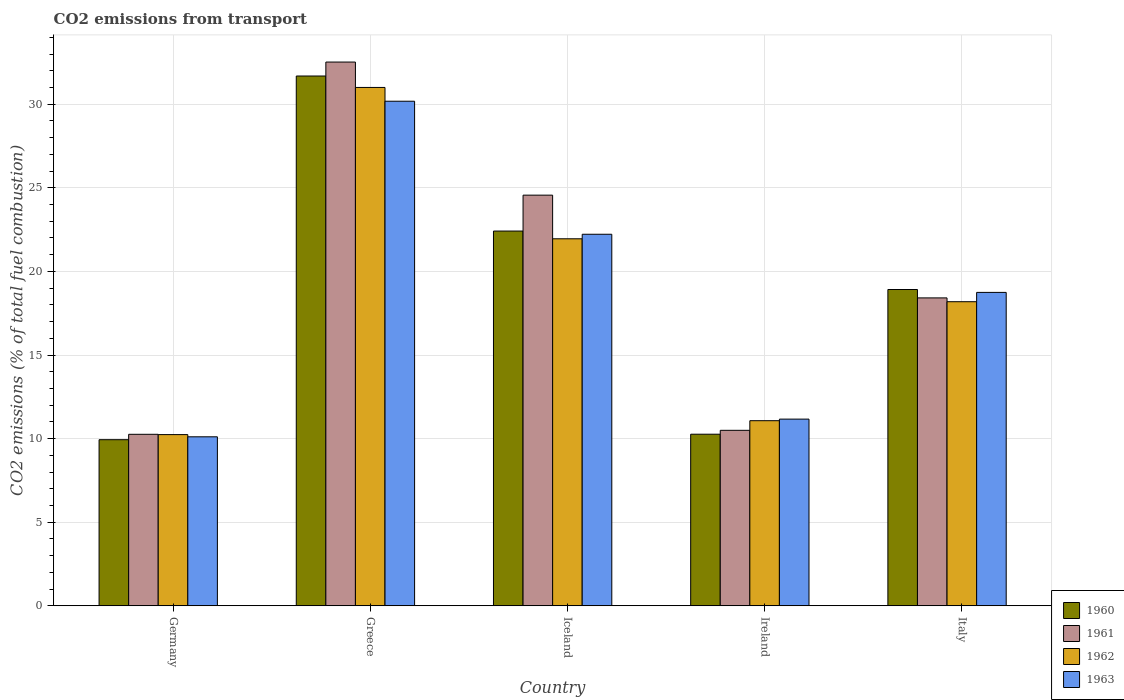How many groups of bars are there?
Provide a succinct answer. 5. What is the label of the 5th group of bars from the left?
Keep it short and to the point. Italy. What is the total CO2 emitted in 1962 in Iceland?
Give a very brief answer. 21.95. Across all countries, what is the maximum total CO2 emitted in 1963?
Your answer should be very brief. 30.18. Across all countries, what is the minimum total CO2 emitted in 1960?
Make the answer very short. 9.93. In which country was the total CO2 emitted in 1961 maximum?
Give a very brief answer. Greece. What is the total total CO2 emitted in 1961 in the graph?
Keep it short and to the point. 96.25. What is the difference between the total CO2 emitted in 1961 in Germany and that in Greece?
Offer a very short reply. -22.26. What is the difference between the total CO2 emitted in 1960 in Greece and the total CO2 emitted in 1962 in Iceland?
Make the answer very short. 9.74. What is the average total CO2 emitted in 1963 per country?
Your answer should be compact. 18.48. What is the difference between the total CO2 emitted of/in 1962 and total CO2 emitted of/in 1963 in Iceland?
Keep it short and to the point. -0.27. In how many countries, is the total CO2 emitted in 1963 greater than 1?
Ensure brevity in your answer.  5. What is the ratio of the total CO2 emitted in 1961 in Iceland to that in Italy?
Provide a succinct answer. 1.33. Is the total CO2 emitted in 1963 in Greece less than that in Iceland?
Offer a very short reply. No. Is the difference between the total CO2 emitted in 1962 in Greece and Italy greater than the difference between the total CO2 emitted in 1963 in Greece and Italy?
Offer a very short reply. Yes. What is the difference between the highest and the second highest total CO2 emitted in 1963?
Your response must be concise. -11.43. What is the difference between the highest and the lowest total CO2 emitted in 1962?
Your answer should be compact. 20.76. In how many countries, is the total CO2 emitted in 1961 greater than the average total CO2 emitted in 1961 taken over all countries?
Give a very brief answer. 2. Is it the case that in every country, the sum of the total CO2 emitted in 1962 and total CO2 emitted in 1960 is greater than the sum of total CO2 emitted in 1963 and total CO2 emitted in 1961?
Ensure brevity in your answer.  No. What does the 3rd bar from the left in Germany represents?
Your answer should be compact. 1962. What does the 4th bar from the right in Greece represents?
Provide a short and direct response. 1960. How many bars are there?
Your answer should be compact. 20. Are all the bars in the graph horizontal?
Your answer should be compact. No. How many countries are there in the graph?
Give a very brief answer. 5. Are the values on the major ticks of Y-axis written in scientific E-notation?
Keep it short and to the point. No. How many legend labels are there?
Offer a very short reply. 4. What is the title of the graph?
Your answer should be compact. CO2 emissions from transport. What is the label or title of the X-axis?
Offer a very short reply. Country. What is the label or title of the Y-axis?
Make the answer very short. CO2 emissions (% of total fuel combustion). What is the CO2 emissions (% of total fuel combustion) of 1960 in Germany?
Give a very brief answer. 9.93. What is the CO2 emissions (% of total fuel combustion) of 1961 in Germany?
Your answer should be compact. 10.26. What is the CO2 emissions (% of total fuel combustion) of 1962 in Germany?
Give a very brief answer. 10.24. What is the CO2 emissions (% of total fuel combustion) in 1963 in Germany?
Keep it short and to the point. 10.11. What is the CO2 emissions (% of total fuel combustion) of 1960 in Greece?
Make the answer very short. 31.69. What is the CO2 emissions (% of total fuel combustion) of 1961 in Greece?
Give a very brief answer. 32.52. What is the CO2 emissions (% of total fuel combustion) of 1962 in Greece?
Give a very brief answer. 31. What is the CO2 emissions (% of total fuel combustion) of 1963 in Greece?
Keep it short and to the point. 30.18. What is the CO2 emissions (% of total fuel combustion) in 1960 in Iceland?
Ensure brevity in your answer.  22.41. What is the CO2 emissions (% of total fuel combustion) in 1961 in Iceland?
Your answer should be very brief. 24.56. What is the CO2 emissions (% of total fuel combustion) in 1962 in Iceland?
Ensure brevity in your answer.  21.95. What is the CO2 emissions (% of total fuel combustion) of 1963 in Iceland?
Keep it short and to the point. 22.22. What is the CO2 emissions (% of total fuel combustion) in 1960 in Ireland?
Keep it short and to the point. 10.26. What is the CO2 emissions (% of total fuel combustion) of 1961 in Ireland?
Provide a short and direct response. 10.5. What is the CO2 emissions (% of total fuel combustion) in 1962 in Ireland?
Offer a very short reply. 11.07. What is the CO2 emissions (% of total fuel combustion) in 1963 in Ireland?
Offer a very short reply. 11.17. What is the CO2 emissions (% of total fuel combustion) of 1960 in Italy?
Provide a short and direct response. 18.92. What is the CO2 emissions (% of total fuel combustion) of 1961 in Italy?
Offer a terse response. 18.42. What is the CO2 emissions (% of total fuel combustion) of 1962 in Italy?
Offer a very short reply. 18.19. What is the CO2 emissions (% of total fuel combustion) of 1963 in Italy?
Keep it short and to the point. 18.74. Across all countries, what is the maximum CO2 emissions (% of total fuel combustion) in 1960?
Give a very brief answer. 31.69. Across all countries, what is the maximum CO2 emissions (% of total fuel combustion) of 1961?
Give a very brief answer. 32.52. Across all countries, what is the maximum CO2 emissions (% of total fuel combustion) of 1962?
Provide a succinct answer. 31. Across all countries, what is the maximum CO2 emissions (% of total fuel combustion) of 1963?
Provide a short and direct response. 30.18. Across all countries, what is the minimum CO2 emissions (% of total fuel combustion) of 1960?
Your answer should be compact. 9.93. Across all countries, what is the minimum CO2 emissions (% of total fuel combustion) in 1961?
Make the answer very short. 10.26. Across all countries, what is the minimum CO2 emissions (% of total fuel combustion) of 1962?
Your response must be concise. 10.24. Across all countries, what is the minimum CO2 emissions (% of total fuel combustion) in 1963?
Provide a succinct answer. 10.11. What is the total CO2 emissions (% of total fuel combustion) in 1960 in the graph?
Offer a terse response. 93.21. What is the total CO2 emissions (% of total fuel combustion) of 1961 in the graph?
Give a very brief answer. 96.25. What is the total CO2 emissions (% of total fuel combustion) of 1962 in the graph?
Offer a terse response. 92.45. What is the total CO2 emissions (% of total fuel combustion) of 1963 in the graph?
Offer a terse response. 92.42. What is the difference between the CO2 emissions (% of total fuel combustion) in 1960 in Germany and that in Greece?
Your answer should be very brief. -21.75. What is the difference between the CO2 emissions (% of total fuel combustion) of 1961 in Germany and that in Greece?
Offer a very short reply. -22.26. What is the difference between the CO2 emissions (% of total fuel combustion) of 1962 in Germany and that in Greece?
Your response must be concise. -20.76. What is the difference between the CO2 emissions (% of total fuel combustion) in 1963 in Germany and that in Greece?
Give a very brief answer. -20.07. What is the difference between the CO2 emissions (% of total fuel combustion) in 1960 in Germany and that in Iceland?
Offer a terse response. -12.48. What is the difference between the CO2 emissions (% of total fuel combustion) in 1961 in Germany and that in Iceland?
Your answer should be compact. -14.3. What is the difference between the CO2 emissions (% of total fuel combustion) of 1962 in Germany and that in Iceland?
Keep it short and to the point. -11.71. What is the difference between the CO2 emissions (% of total fuel combustion) of 1963 in Germany and that in Iceland?
Your answer should be very brief. -12.12. What is the difference between the CO2 emissions (% of total fuel combustion) in 1960 in Germany and that in Ireland?
Ensure brevity in your answer.  -0.33. What is the difference between the CO2 emissions (% of total fuel combustion) in 1961 in Germany and that in Ireland?
Ensure brevity in your answer.  -0.24. What is the difference between the CO2 emissions (% of total fuel combustion) in 1962 in Germany and that in Ireland?
Your answer should be very brief. -0.83. What is the difference between the CO2 emissions (% of total fuel combustion) in 1963 in Germany and that in Ireland?
Ensure brevity in your answer.  -1.06. What is the difference between the CO2 emissions (% of total fuel combustion) of 1960 in Germany and that in Italy?
Provide a short and direct response. -8.98. What is the difference between the CO2 emissions (% of total fuel combustion) of 1961 in Germany and that in Italy?
Ensure brevity in your answer.  -8.16. What is the difference between the CO2 emissions (% of total fuel combustion) of 1962 in Germany and that in Italy?
Provide a short and direct response. -7.95. What is the difference between the CO2 emissions (% of total fuel combustion) in 1963 in Germany and that in Italy?
Your answer should be compact. -8.64. What is the difference between the CO2 emissions (% of total fuel combustion) in 1960 in Greece and that in Iceland?
Give a very brief answer. 9.27. What is the difference between the CO2 emissions (% of total fuel combustion) of 1961 in Greece and that in Iceland?
Ensure brevity in your answer.  7.96. What is the difference between the CO2 emissions (% of total fuel combustion) of 1962 in Greece and that in Iceland?
Give a very brief answer. 9.05. What is the difference between the CO2 emissions (% of total fuel combustion) of 1963 in Greece and that in Iceland?
Make the answer very short. 7.96. What is the difference between the CO2 emissions (% of total fuel combustion) in 1960 in Greece and that in Ireland?
Ensure brevity in your answer.  21.42. What is the difference between the CO2 emissions (% of total fuel combustion) of 1961 in Greece and that in Ireland?
Provide a succinct answer. 22.03. What is the difference between the CO2 emissions (% of total fuel combustion) in 1962 in Greece and that in Ireland?
Offer a terse response. 19.93. What is the difference between the CO2 emissions (% of total fuel combustion) of 1963 in Greece and that in Ireland?
Provide a succinct answer. 19.01. What is the difference between the CO2 emissions (% of total fuel combustion) in 1960 in Greece and that in Italy?
Ensure brevity in your answer.  12.77. What is the difference between the CO2 emissions (% of total fuel combustion) in 1961 in Greece and that in Italy?
Your answer should be very brief. 14.11. What is the difference between the CO2 emissions (% of total fuel combustion) in 1962 in Greece and that in Italy?
Provide a succinct answer. 12.82. What is the difference between the CO2 emissions (% of total fuel combustion) in 1963 in Greece and that in Italy?
Your response must be concise. 11.43. What is the difference between the CO2 emissions (% of total fuel combustion) of 1960 in Iceland and that in Ireland?
Keep it short and to the point. 12.15. What is the difference between the CO2 emissions (% of total fuel combustion) in 1961 in Iceland and that in Ireland?
Keep it short and to the point. 14.07. What is the difference between the CO2 emissions (% of total fuel combustion) of 1962 in Iceland and that in Ireland?
Your response must be concise. 10.88. What is the difference between the CO2 emissions (% of total fuel combustion) in 1963 in Iceland and that in Ireland?
Your answer should be very brief. 11.06. What is the difference between the CO2 emissions (% of total fuel combustion) of 1960 in Iceland and that in Italy?
Provide a succinct answer. 3.5. What is the difference between the CO2 emissions (% of total fuel combustion) of 1961 in Iceland and that in Italy?
Make the answer very short. 6.15. What is the difference between the CO2 emissions (% of total fuel combustion) in 1962 in Iceland and that in Italy?
Provide a succinct answer. 3.76. What is the difference between the CO2 emissions (% of total fuel combustion) of 1963 in Iceland and that in Italy?
Your answer should be compact. 3.48. What is the difference between the CO2 emissions (% of total fuel combustion) of 1960 in Ireland and that in Italy?
Make the answer very short. -8.65. What is the difference between the CO2 emissions (% of total fuel combustion) in 1961 in Ireland and that in Italy?
Make the answer very short. -7.92. What is the difference between the CO2 emissions (% of total fuel combustion) of 1962 in Ireland and that in Italy?
Provide a succinct answer. -7.12. What is the difference between the CO2 emissions (% of total fuel combustion) of 1963 in Ireland and that in Italy?
Make the answer very short. -7.58. What is the difference between the CO2 emissions (% of total fuel combustion) in 1960 in Germany and the CO2 emissions (% of total fuel combustion) in 1961 in Greece?
Make the answer very short. -22.59. What is the difference between the CO2 emissions (% of total fuel combustion) in 1960 in Germany and the CO2 emissions (% of total fuel combustion) in 1962 in Greece?
Your answer should be compact. -21.07. What is the difference between the CO2 emissions (% of total fuel combustion) in 1960 in Germany and the CO2 emissions (% of total fuel combustion) in 1963 in Greece?
Provide a short and direct response. -20.24. What is the difference between the CO2 emissions (% of total fuel combustion) in 1961 in Germany and the CO2 emissions (% of total fuel combustion) in 1962 in Greece?
Your response must be concise. -20.75. What is the difference between the CO2 emissions (% of total fuel combustion) in 1961 in Germany and the CO2 emissions (% of total fuel combustion) in 1963 in Greece?
Your answer should be compact. -19.92. What is the difference between the CO2 emissions (% of total fuel combustion) in 1962 in Germany and the CO2 emissions (% of total fuel combustion) in 1963 in Greece?
Ensure brevity in your answer.  -19.94. What is the difference between the CO2 emissions (% of total fuel combustion) in 1960 in Germany and the CO2 emissions (% of total fuel combustion) in 1961 in Iceland?
Your response must be concise. -14.63. What is the difference between the CO2 emissions (% of total fuel combustion) in 1960 in Germany and the CO2 emissions (% of total fuel combustion) in 1962 in Iceland?
Provide a succinct answer. -12.02. What is the difference between the CO2 emissions (% of total fuel combustion) in 1960 in Germany and the CO2 emissions (% of total fuel combustion) in 1963 in Iceland?
Offer a terse response. -12.29. What is the difference between the CO2 emissions (% of total fuel combustion) of 1961 in Germany and the CO2 emissions (% of total fuel combustion) of 1962 in Iceland?
Provide a short and direct response. -11.69. What is the difference between the CO2 emissions (% of total fuel combustion) of 1961 in Germany and the CO2 emissions (% of total fuel combustion) of 1963 in Iceland?
Make the answer very short. -11.96. What is the difference between the CO2 emissions (% of total fuel combustion) in 1962 in Germany and the CO2 emissions (% of total fuel combustion) in 1963 in Iceland?
Your answer should be compact. -11.98. What is the difference between the CO2 emissions (% of total fuel combustion) in 1960 in Germany and the CO2 emissions (% of total fuel combustion) in 1961 in Ireland?
Your response must be concise. -0.56. What is the difference between the CO2 emissions (% of total fuel combustion) in 1960 in Germany and the CO2 emissions (% of total fuel combustion) in 1962 in Ireland?
Keep it short and to the point. -1.14. What is the difference between the CO2 emissions (% of total fuel combustion) in 1960 in Germany and the CO2 emissions (% of total fuel combustion) in 1963 in Ireland?
Provide a short and direct response. -1.23. What is the difference between the CO2 emissions (% of total fuel combustion) of 1961 in Germany and the CO2 emissions (% of total fuel combustion) of 1962 in Ireland?
Provide a succinct answer. -0.81. What is the difference between the CO2 emissions (% of total fuel combustion) in 1961 in Germany and the CO2 emissions (% of total fuel combustion) in 1963 in Ireland?
Offer a terse response. -0.91. What is the difference between the CO2 emissions (% of total fuel combustion) of 1962 in Germany and the CO2 emissions (% of total fuel combustion) of 1963 in Ireland?
Your answer should be very brief. -0.93. What is the difference between the CO2 emissions (% of total fuel combustion) of 1960 in Germany and the CO2 emissions (% of total fuel combustion) of 1961 in Italy?
Your answer should be compact. -8.48. What is the difference between the CO2 emissions (% of total fuel combustion) in 1960 in Germany and the CO2 emissions (% of total fuel combustion) in 1962 in Italy?
Offer a terse response. -8.25. What is the difference between the CO2 emissions (% of total fuel combustion) of 1960 in Germany and the CO2 emissions (% of total fuel combustion) of 1963 in Italy?
Give a very brief answer. -8.81. What is the difference between the CO2 emissions (% of total fuel combustion) in 1961 in Germany and the CO2 emissions (% of total fuel combustion) in 1962 in Italy?
Your answer should be compact. -7.93. What is the difference between the CO2 emissions (% of total fuel combustion) of 1961 in Germany and the CO2 emissions (% of total fuel combustion) of 1963 in Italy?
Your answer should be very brief. -8.49. What is the difference between the CO2 emissions (% of total fuel combustion) in 1962 in Germany and the CO2 emissions (% of total fuel combustion) in 1963 in Italy?
Provide a succinct answer. -8.51. What is the difference between the CO2 emissions (% of total fuel combustion) in 1960 in Greece and the CO2 emissions (% of total fuel combustion) in 1961 in Iceland?
Provide a succinct answer. 7.13. What is the difference between the CO2 emissions (% of total fuel combustion) of 1960 in Greece and the CO2 emissions (% of total fuel combustion) of 1962 in Iceland?
Make the answer very short. 9.74. What is the difference between the CO2 emissions (% of total fuel combustion) of 1960 in Greece and the CO2 emissions (% of total fuel combustion) of 1963 in Iceland?
Ensure brevity in your answer.  9.46. What is the difference between the CO2 emissions (% of total fuel combustion) of 1961 in Greece and the CO2 emissions (% of total fuel combustion) of 1962 in Iceland?
Ensure brevity in your answer.  10.57. What is the difference between the CO2 emissions (% of total fuel combustion) of 1961 in Greece and the CO2 emissions (% of total fuel combustion) of 1963 in Iceland?
Provide a short and direct response. 10.3. What is the difference between the CO2 emissions (% of total fuel combustion) of 1962 in Greece and the CO2 emissions (% of total fuel combustion) of 1963 in Iceland?
Make the answer very short. 8.78. What is the difference between the CO2 emissions (% of total fuel combustion) in 1960 in Greece and the CO2 emissions (% of total fuel combustion) in 1961 in Ireland?
Offer a terse response. 21.19. What is the difference between the CO2 emissions (% of total fuel combustion) in 1960 in Greece and the CO2 emissions (% of total fuel combustion) in 1962 in Ireland?
Provide a succinct answer. 20.62. What is the difference between the CO2 emissions (% of total fuel combustion) in 1960 in Greece and the CO2 emissions (% of total fuel combustion) in 1963 in Ireland?
Keep it short and to the point. 20.52. What is the difference between the CO2 emissions (% of total fuel combustion) in 1961 in Greece and the CO2 emissions (% of total fuel combustion) in 1962 in Ireland?
Give a very brief answer. 21.45. What is the difference between the CO2 emissions (% of total fuel combustion) in 1961 in Greece and the CO2 emissions (% of total fuel combustion) in 1963 in Ireland?
Offer a terse response. 21.36. What is the difference between the CO2 emissions (% of total fuel combustion) of 1962 in Greece and the CO2 emissions (% of total fuel combustion) of 1963 in Ireland?
Your response must be concise. 19.84. What is the difference between the CO2 emissions (% of total fuel combustion) of 1960 in Greece and the CO2 emissions (% of total fuel combustion) of 1961 in Italy?
Provide a short and direct response. 13.27. What is the difference between the CO2 emissions (% of total fuel combustion) in 1960 in Greece and the CO2 emissions (% of total fuel combustion) in 1962 in Italy?
Keep it short and to the point. 13.5. What is the difference between the CO2 emissions (% of total fuel combustion) in 1960 in Greece and the CO2 emissions (% of total fuel combustion) in 1963 in Italy?
Ensure brevity in your answer.  12.94. What is the difference between the CO2 emissions (% of total fuel combustion) in 1961 in Greece and the CO2 emissions (% of total fuel combustion) in 1962 in Italy?
Provide a succinct answer. 14.33. What is the difference between the CO2 emissions (% of total fuel combustion) in 1961 in Greece and the CO2 emissions (% of total fuel combustion) in 1963 in Italy?
Your answer should be compact. 13.78. What is the difference between the CO2 emissions (% of total fuel combustion) in 1962 in Greece and the CO2 emissions (% of total fuel combustion) in 1963 in Italy?
Provide a succinct answer. 12.26. What is the difference between the CO2 emissions (% of total fuel combustion) of 1960 in Iceland and the CO2 emissions (% of total fuel combustion) of 1961 in Ireland?
Keep it short and to the point. 11.92. What is the difference between the CO2 emissions (% of total fuel combustion) of 1960 in Iceland and the CO2 emissions (% of total fuel combustion) of 1962 in Ireland?
Make the answer very short. 11.34. What is the difference between the CO2 emissions (% of total fuel combustion) of 1960 in Iceland and the CO2 emissions (% of total fuel combustion) of 1963 in Ireland?
Your response must be concise. 11.25. What is the difference between the CO2 emissions (% of total fuel combustion) of 1961 in Iceland and the CO2 emissions (% of total fuel combustion) of 1962 in Ireland?
Make the answer very short. 13.49. What is the difference between the CO2 emissions (% of total fuel combustion) in 1961 in Iceland and the CO2 emissions (% of total fuel combustion) in 1963 in Ireland?
Your response must be concise. 13.4. What is the difference between the CO2 emissions (% of total fuel combustion) in 1962 in Iceland and the CO2 emissions (% of total fuel combustion) in 1963 in Ireland?
Offer a very short reply. 10.79. What is the difference between the CO2 emissions (% of total fuel combustion) in 1960 in Iceland and the CO2 emissions (% of total fuel combustion) in 1961 in Italy?
Keep it short and to the point. 4. What is the difference between the CO2 emissions (% of total fuel combustion) of 1960 in Iceland and the CO2 emissions (% of total fuel combustion) of 1962 in Italy?
Make the answer very short. 4.23. What is the difference between the CO2 emissions (% of total fuel combustion) of 1960 in Iceland and the CO2 emissions (% of total fuel combustion) of 1963 in Italy?
Offer a terse response. 3.67. What is the difference between the CO2 emissions (% of total fuel combustion) in 1961 in Iceland and the CO2 emissions (% of total fuel combustion) in 1962 in Italy?
Your response must be concise. 6.37. What is the difference between the CO2 emissions (% of total fuel combustion) of 1961 in Iceland and the CO2 emissions (% of total fuel combustion) of 1963 in Italy?
Keep it short and to the point. 5.82. What is the difference between the CO2 emissions (% of total fuel combustion) of 1962 in Iceland and the CO2 emissions (% of total fuel combustion) of 1963 in Italy?
Provide a succinct answer. 3.21. What is the difference between the CO2 emissions (% of total fuel combustion) of 1960 in Ireland and the CO2 emissions (% of total fuel combustion) of 1961 in Italy?
Your response must be concise. -8.15. What is the difference between the CO2 emissions (% of total fuel combustion) of 1960 in Ireland and the CO2 emissions (% of total fuel combustion) of 1962 in Italy?
Make the answer very short. -7.92. What is the difference between the CO2 emissions (% of total fuel combustion) in 1960 in Ireland and the CO2 emissions (% of total fuel combustion) in 1963 in Italy?
Give a very brief answer. -8.48. What is the difference between the CO2 emissions (% of total fuel combustion) in 1961 in Ireland and the CO2 emissions (% of total fuel combustion) in 1962 in Italy?
Offer a terse response. -7.69. What is the difference between the CO2 emissions (% of total fuel combustion) in 1961 in Ireland and the CO2 emissions (% of total fuel combustion) in 1963 in Italy?
Offer a terse response. -8.25. What is the difference between the CO2 emissions (% of total fuel combustion) of 1962 in Ireland and the CO2 emissions (% of total fuel combustion) of 1963 in Italy?
Make the answer very short. -7.67. What is the average CO2 emissions (% of total fuel combustion) in 1960 per country?
Keep it short and to the point. 18.64. What is the average CO2 emissions (% of total fuel combustion) in 1961 per country?
Offer a terse response. 19.25. What is the average CO2 emissions (% of total fuel combustion) of 1962 per country?
Offer a very short reply. 18.49. What is the average CO2 emissions (% of total fuel combustion) in 1963 per country?
Offer a very short reply. 18.48. What is the difference between the CO2 emissions (% of total fuel combustion) in 1960 and CO2 emissions (% of total fuel combustion) in 1961 in Germany?
Give a very brief answer. -0.32. What is the difference between the CO2 emissions (% of total fuel combustion) in 1960 and CO2 emissions (% of total fuel combustion) in 1962 in Germany?
Provide a short and direct response. -0.3. What is the difference between the CO2 emissions (% of total fuel combustion) in 1960 and CO2 emissions (% of total fuel combustion) in 1963 in Germany?
Your answer should be very brief. -0.17. What is the difference between the CO2 emissions (% of total fuel combustion) in 1961 and CO2 emissions (% of total fuel combustion) in 1962 in Germany?
Give a very brief answer. 0.02. What is the difference between the CO2 emissions (% of total fuel combustion) in 1961 and CO2 emissions (% of total fuel combustion) in 1963 in Germany?
Ensure brevity in your answer.  0.15. What is the difference between the CO2 emissions (% of total fuel combustion) of 1962 and CO2 emissions (% of total fuel combustion) of 1963 in Germany?
Offer a very short reply. 0.13. What is the difference between the CO2 emissions (% of total fuel combustion) of 1960 and CO2 emissions (% of total fuel combustion) of 1961 in Greece?
Make the answer very short. -0.83. What is the difference between the CO2 emissions (% of total fuel combustion) in 1960 and CO2 emissions (% of total fuel combustion) in 1962 in Greece?
Offer a very short reply. 0.68. What is the difference between the CO2 emissions (% of total fuel combustion) in 1960 and CO2 emissions (% of total fuel combustion) in 1963 in Greece?
Make the answer very short. 1.51. What is the difference between the CO2 emissions (% of total fuel combustion) in 1961 and CO2 emissions (% of total fuel combustion) in 1962 in Greece?
Give a very brief answer. 1.52. What is the difference between the CO2 emissions (% of total fuel combustion) of 1961 and CO2 emissions (% of total fuel combustion) of 1963 in Greece?
Keep it short and to the point. 2.34. What is the difference between the CO2 emissions (% of total fuel combustion) of 1962 and CO2 emissions (% of total fuel combustion) of 1963 in Greece?
Your answer should be compact. 0.82. What is the difference between the CO2 emissions (% of total fuel combustion) in 1960 and CO2 emissions (% of total fuel combustion) in 1961 in Iceland?
Make the answer very short. -2.15. What is the difference between the CO2 emissions (% of total fuel combustion) of 1960 and CO2 emissions (% of total fuel combustion) of 1962 in Iceland?
Provide a succinct answer. 0.46. What is the difference between the CO2 emissions (% of total fuel combustion) in 1960 and CO2 emissions (% of total fuel combustion) in 1963 in Iceland?
Offer a very short reply. 0.19. What is the difference between the CO2 emissions (% of total fuel combustion) in 1961 and CO2 emissions (% of total fuel combustion) in 1962 in Iceland?
Your answer should be very brief. 2.61. What is the difference between the CO2 emissions (% of total fuel combustion) in 1961 and CO2 emissions (% of total fuel combustion) in 1963 in Iceland?
Your answer should be very brief. 2.34. What is the difference between the CO2 emissions (% of total fuel combustion) of 1962 and CO2 emissions (% of total fuel combustion) of 1963 in Iceland?
Keep it short and to the point. -0.27. What is the difference between the CO2 emissions (% of total fuel combustion) in 1960 and CO2 emissions (% of total fuel combustion) in 1961 in Ireland?
Your answer should be very brief. -0.23. What is the difference between the CO2 emissions (% of total fuel combustion) in 1960 and CO2 emissions (% of total fuel combustion) in 1962 in Ireland?
Provide a succinct answer. -0.81. What is the difference between the CO2 emissions (% of total fuel combustion) of 1960 and CO2 emissions (% of total fuel combustion) of 1963 in Ireland?
Make the answer very short. -0.9. What is the difference between the CO2 emissions (% of total fuel combustion) in 1961 and CO2 emissions (% of total fuel combustion) in 1962 in Ireland?
Offer a very short reply. -0.58. What is the difference between the CO2 emissions (% of total fuel combustion) in 1961 and CO2 emissions (% of total fuel combustion) in 1963 in Ireland?
Your answer should be very brief. -0.67. What is the difference between the CO2 emissions (% of total fuel combustion) in 1962 and CO2 emissions (% of total fuel combustion) in 1963 in Ireland?
Provide a short and direct response. -0.09. What is the difference between the CO2 emissions (% of total fuel combustion) in 1960 and CO2 emissions (% of total fuel combustion) in 1961 in Italy?
Give a very brief answer. 0.5. What is the difference between the CO2 emissions (% of total fuel combustion) of 1960 and CO2 emissions (% of total fuel combustion) of 1962 in Italy?
Offer a very short reply. 0.73. What is the difference between the CO2 emissions (% of total fuel combustion) in 1960 and CO2 emissions (% of total fuel combustion) in 1963 in Italy?
Your answer should be compact. 0.17. What is the difference between the CO2 emissions (% of total fuel combustion) of 1961 and CO2 emissions (% of total fuel combustion) of 1962 in Italy?
Offer a terse response. 0.23. What is the difference between the CO2 emissions (% of total fuel combustion) of 1961 and CO2 emissions (% of total fuel combustion) of 1963 in Italy?
Your answer should be very brief. -0.33. What is the difference between the CO2 emissions (% of total fuel combustion) in 1962 and CO2 emissions (% of total fuel combustion) in 1963 in Italy?
Keep it short and to the point. -0.56. What is the ratio of the CO2 emissions (% of total fuel combustion) of 1960 in Germany to that in Greece?
Provide a succinct answer. 0.31. What is the ratio of the CO2 emissions (% of total fuel combustion) in 1961 in Germany to that in Greece?
Offer a terse response. 0.32. What is the ratio of the CO2 emissions (% of total fuel combustion) of 1962 in Germany to that in Greece?
Offer a terse response. 0.33. What is the ratio of the CO2 emissions (% of total fuel combustion) of 1963 in Germany to that in Greece?
Provide a short and direct response. 0.33. What is the ratio of the CO2 emissions (% of total fuel combustion) of 1960 in Germany to that in Iceland?
Give a very brief answer. 0.44. What is the ratio of the CO2 emissions (% of total fuel combustion) in 1961 in Germany to that in Iceland?
Make the answer very short. 0.42. What is the ratio of the CO2 emissions (% of total fuel combustion) of 1962 in Germany to that in Iceland?
Your answer should be very brief. 0.47. What is the ratio of the CO2 emissions (% of total fuel combustion) in 1963 in Germany to that in Iceland?
Your answer should be compact. 0.45. What is the ratio of the CO2 emissions (% of total fuel combustion) of 1961 in Germany to that in Ireland?
Offer a terse response. 0.98. What is the ratio of the CO2 emissions (% of total fuel combustion) of 1962 in Germany to that in Ireland?
Offer a very short reply. 0.92. What is the ratio of the CO2 emissions (% of total fuel combustion) in 1963 in Germany to that in Ireland?
Your answer should be very brief. 0.91. What is the ratio of the CO2 emissions (% of total fuel combustion) of 1960 in Germany to that in Italy?
Your response must be concise. 0.53. What is the ratio of the CO2 emissions (% of total fuel combustion) in 1961 in Germany to that in Italy?
Your answer should be very brief. 0.56. What is the ratio of the CO2 emissions (% of total fuel combustion) of 1962 in Germany to that in Italy?
Your answer should be very brief. 0.56. What is the ratio of the CO2 emissions (% of total fuel combustion) in 1963 in Germany to that in Italy?
Give a very brief answer. 0.54. What is the ratio of the CO2 emissions (% of total fuel combustion) in 1960 in Greece to that in Iceland?
Offer a terse response. 1.41. What is the ratio of the CO2 emissions (% of total fuel combustion) in 1961 in Greece to that in Iceland?
Keep it short and to the point. 1.32. What is the ratio of the CO2 emissions (% of total fuel combustion) of 1962 in Greece to that in Iceland?
Offer a very short reply. 1.41. What is the ratio of the CO2 emissions (% of total fuel combustion) of 1963 in Greece to that in Iceland?
Offer a very short reply. 1.36. What is the ratio of the CO2 emissions (% of total fuel combustion) in 1960 in Greece to that in Ireland?
Provide a succinct answer. 3.09. What is the ratio of the CO2 emissions (% of total fuel combustion) of 1961 in Greece to that in Ireland?
Offer a terse response. 3.1. What is the ratio of the CO2 emissions (% of total fuel combustion) in 1962 in Greece to that in Ireland?
Your answer should be compact. 2.8. What is the ratio of the CO2 emissions (% of total fuel combustion) of 1963 in Greece to that in Ireland?
Keep it short and to the point. 2.7. What is the ratio of the CO2 emissions (% of total fuel combustion) in 1960 in Greece to that in Italy?
Your answer should be compact. 1.68. What is the ratio of the CO2 emissions (% of total fuel combustion) in 1961 in Greece to that in Italy?
Offer a very short reply. 1.77. What is the ratio of the CO2 emissions (% of total fuel combustion) of 1962 in Greece to that in Italy?
Your answer should be compact. 1.7. What is the ratio of the CO2 emissions (% of total fuel combustion) in 1963 in Greece to that in Italy?
Provide a succinct answer. 1.61. What is the ratio of the CO2 emissions (% of total fuel combustion) of 1960 in Iceland to that in Ireland?
Make the answer very short. 2.18. What is the ratio of the CO2 emissions (% of total fuel combustion) in 1961 in Iceland to that in Ireland?
Provide a short and direct response. 2.34. What is the ratio of the CO2 emissions (% of total fuel combustion) in 1962 in Iceland to that in Ireland?
Provide a short and direct response. 1.98. What is the ratio of the CO2 emissions (% of total fuel combustion) of 1963 in Iceland to that in Ireland?
Keep it short and to the point. 1.99. What is the ratio of the CO2 emissions (% of total fuel combustion) of 1960 in Iceland to that in Italy?
Offer a terse response. 1.18. What is the ratio of the CO2 emissions (% of total fuel combustion) in 1961 in Iceland to that in Italy?
Your answer should be compact. 1.33. What is the ratio of the CO2 emissions (% of total fuel combustion) of 1962 in Iceland to that in Italy?
Provide a short and direct response. 1.21. What is the ratio of the CO2 emissions (% of total fuel combustion) of 1963 in Iceland to that in Italy?
Give a very brief answer. 1.19. What is the ratio of the CO2 emissions (% of total fuel combustion) in 1960 in Ireland to that in Italy?
Make the answer very short. 0.54. What is the ratio of the CO2 emissions (% of total fuel combustion) in 1961 in Ireland to that in Italy?
Offer a very short reply. 0.57. What is the ratio of the CO2 emissions (% of total fuel combustion) in 1962 in Ireland to that in Italy?
Provide a succinct answer. 0.61. What is the ratio of the CO2 emissions (% of total fuel combustion) of 1963 in Ireland to that in Italy?
Offer a terse response. 0.6. What is the difference between the highest and the second highest CO2 emissions (% of total fuel combustion) of 1960?
Give a very brief answer. 9.27. What is the difference between the highest and the second highest CO2 emissions (% of total fuel combustion) in 1961?
Your answer should be very brief. 7.96. What is the difference between the highest and the second highest CO2 emissions (% of total fuel combustion) in 1962?
Offer a terse response. 9.05. What is the difference between the highest and the second highest CO2 emissions (% of total fuel combustion) in 1963?
Provide a succinct answer. 7.96. What is the difference between the highest and the lowest CO2 emissions (% of total fuel combustion) of 1960?
Your answer should be compact. 21.75. What is the difference between the highest and the lowest CO2 emissions (% of total fuel combustion) in 1961?
Give a very brief answer. 22.26. What is the difference between the highest and the lowest CO2 emissions (% of total fuel combustion) of 1962?
Offer a very short reply. 20.76. What is the difference between the highest and the lowest CO2 emissions (% of total fuel combustion) of 1963?
Offer a terse response. 20.07. 